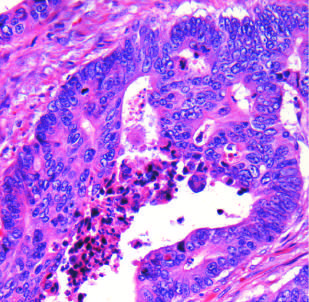what is typical?
Answer the question using a single word or phrase. Necrotic debris 